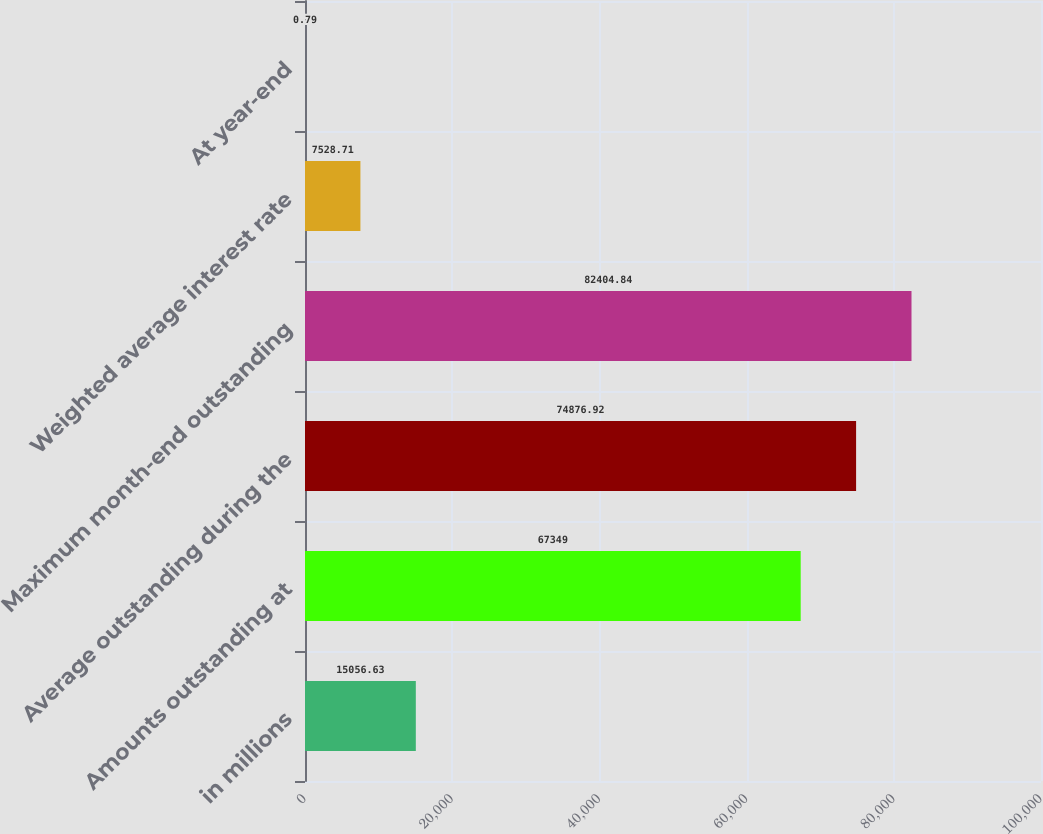Convert chart to OTSL. <chart><loc_0><loc_0><loc_500><loc_500><bar_chart><fcel>in millions<fcel>Amounts outstanding at<fcel>Average outstanding during the<fcel>Maximum month-end outstanding<fcel>Weighted average interest rate<fcel>At year-end<nl><fcel>15056.6<fcel>67349<fcel>74876.9<fcel>82404.8<fcel>7528.71<fcel>0.79<nl></chart> 